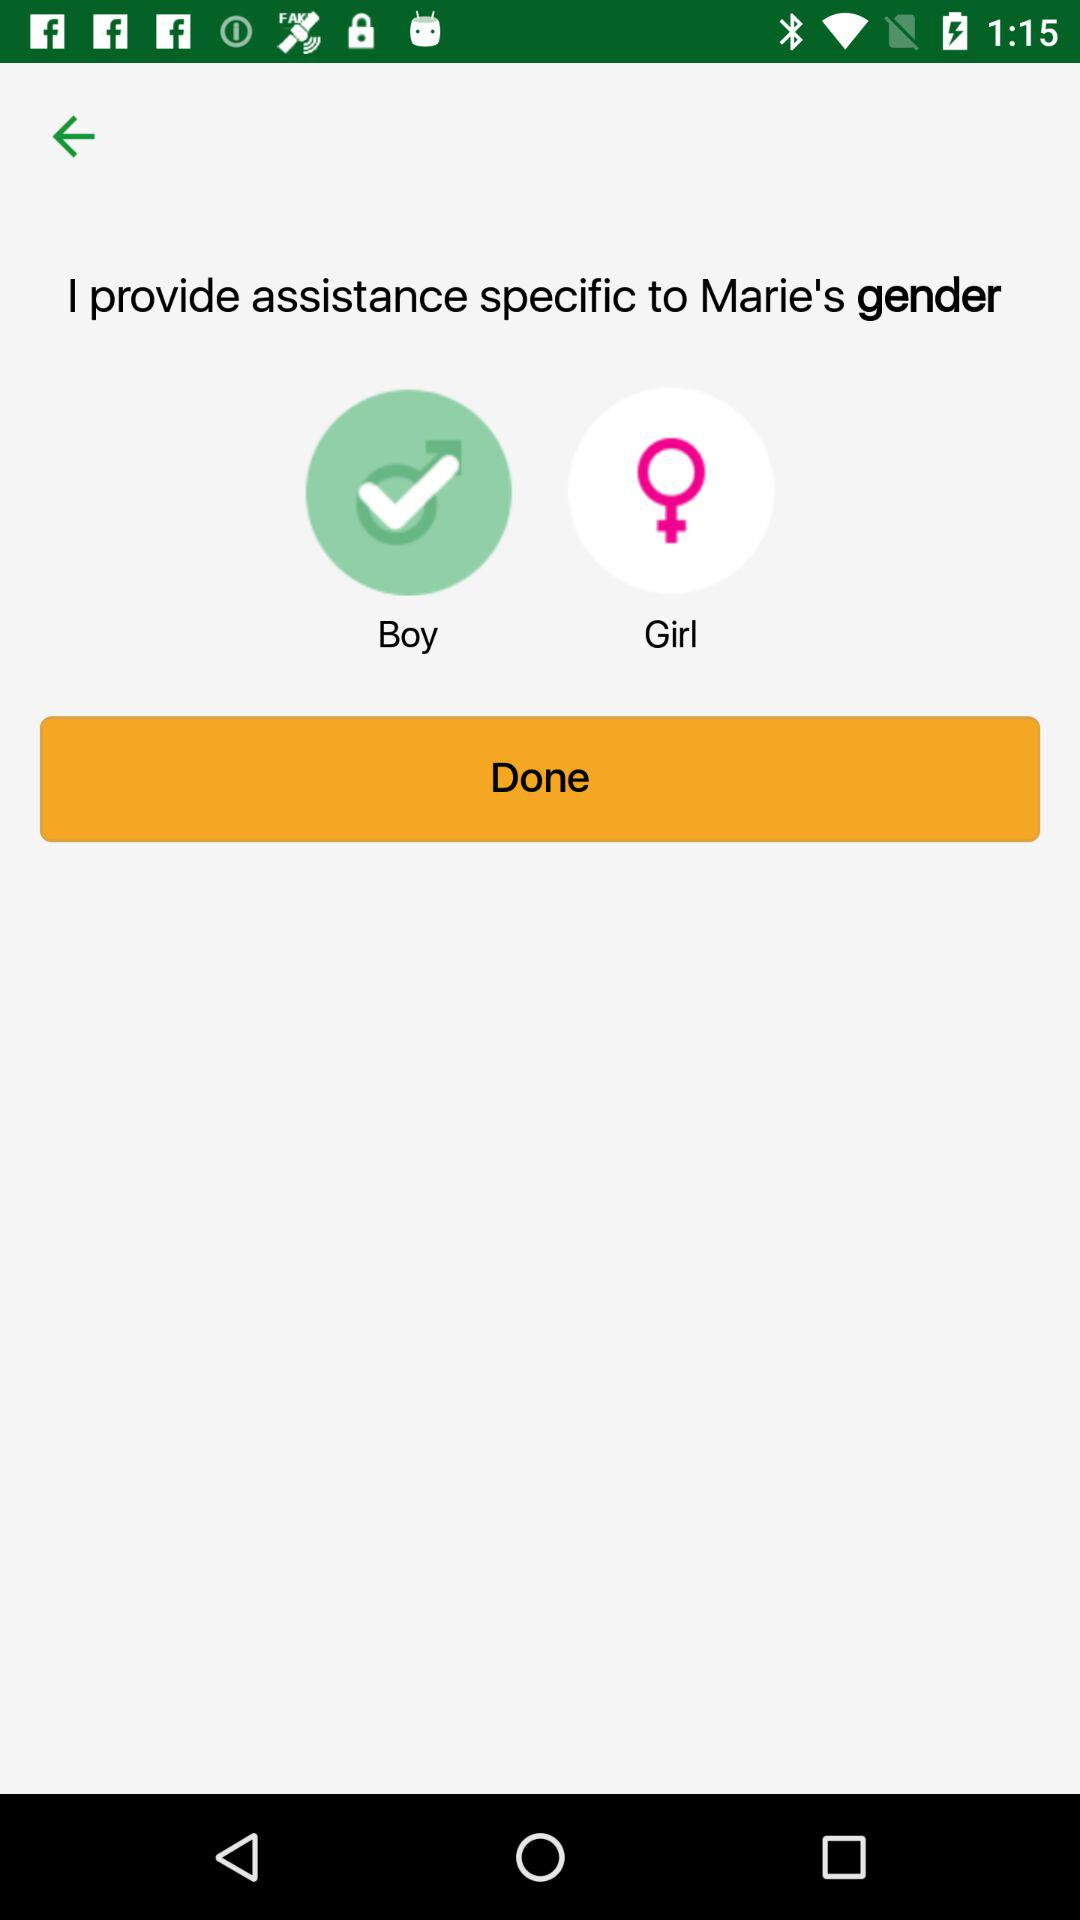Which gender has been selected?
Answer the question using a single word or phrase. It's a boy. 